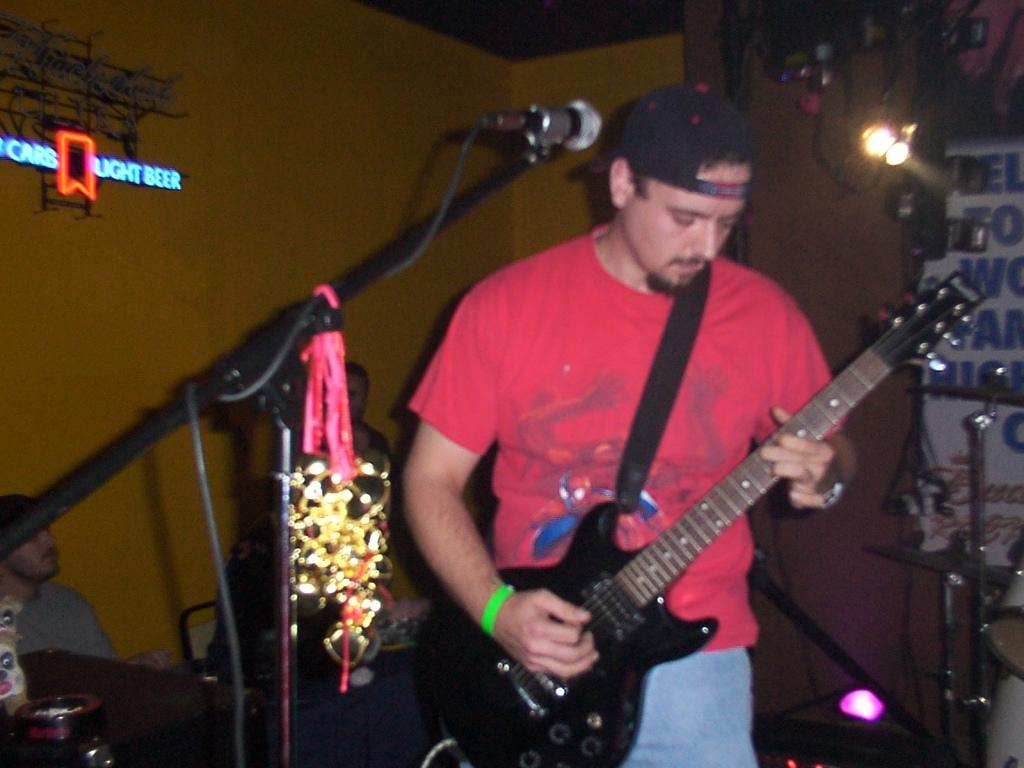What is present in the image? There is a person in the image. What is the person holding in his hand? The person is holding a guitar in his hand. What type of lipstick is the person wearing in the image? There is no lipstick or any indication of lipstick in the image. 